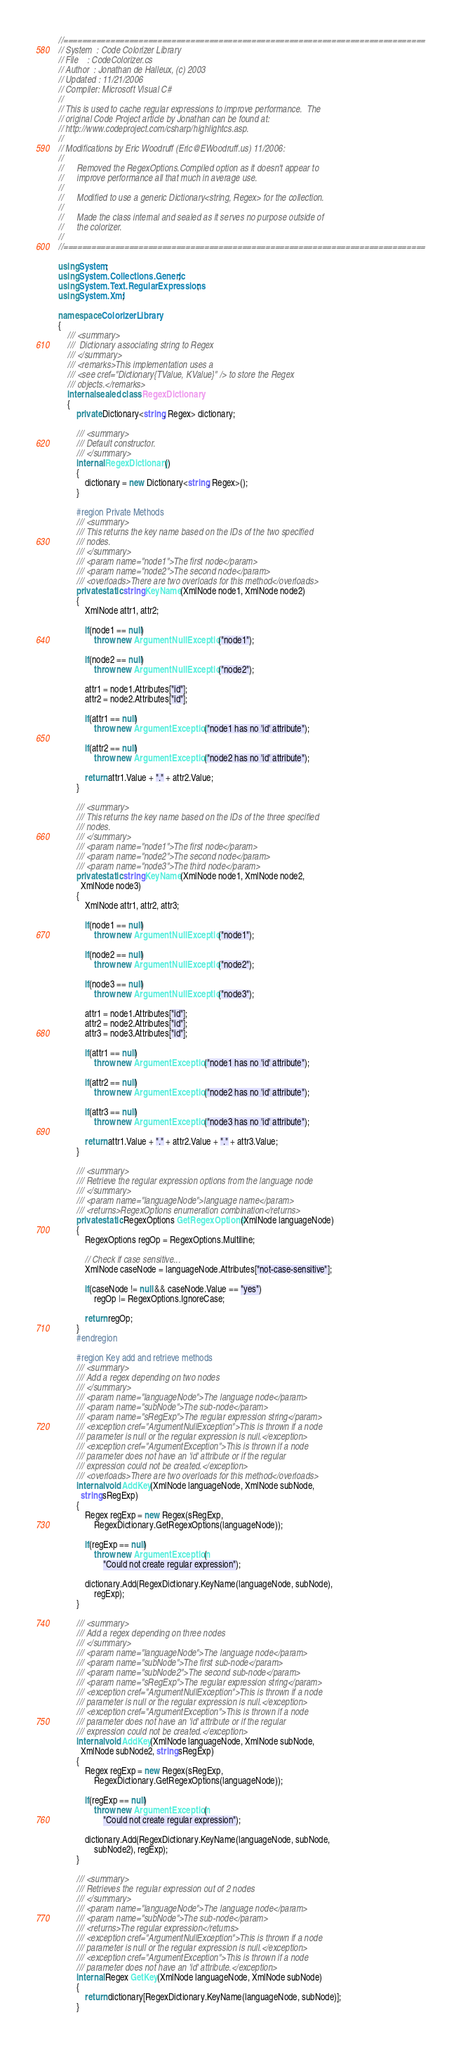Convert code to text. <code><loc_0><loc_0><loc_500><loc_500><_C#_>//=============================================================================
// System  : Code Colorizer Library
// File    : CodeColorizer.cs
// Author  : Jonathan de Halleux, (c) 2003
// Updated : 11/21/2006
// Compiler: Microsoft Visual C#
//
// This is used to cache regular expressions to improve performance.  The
// original Code Project article by Jonathan can be found at:
// http://www.codeproject.com/csharp/highlightcs.asp.
//
// Modifications by Eric Woodruff (Eric@EWoodruff.us) 11/2006:
//
//      Removed the RegexOptions.Compiled option as it doesn't appear to
//      improve performance all that much in average use.
//
//      Modified to use a generic Dictionary<string, Regex> for the collection.
//
//      Made the class internal and sealed as it serves no purpose outside of
//      the colorizer.
//
//=============================================================================

using System;
using System.Collections.Generic;
using System.Text.RegularExpressions;
using System.Xml;

namespace ColorizerLibrary
{
	/// <summary>
	///  Dictionary associating string to Regex
	/// </summary>
	/// <remarks>This implementation uses a
    /// <see cref="Dictionary{TValue, KValue}" /> to store the Regex
    /// objects.</remarks>
	internal sealed class RegexDictionary
	{
        private Dictionary<string, Regex> dictionary;

		/// <summary>
		/// Default constructor.
		/// </summary>
		internal RegexDictionary()
		{
            dictionary = new Dictionary<string, Regex>();
		}

		#region Private Methods
        /// <summary>
        /// This returns the key name based on the IDs of the two specified
        /// nodes.
        /// </summary>
        /// <param name="node1">The first node</param>
        /// <param name="node2">The second node</param>
        /// <overloads>There are two overloads for this method</overloads>
        private static string KeyName(XmlNode node1, XmlNode node2)
        {
            XmlNode attr1, attr2;

            if(node1 == null)
                throw new ArgumentNullException("node1");

            if(node2 == null)
                throw new ArgumentNullException("node2");

            attr1 = node1.Attributes["id"];
            attr2 = node2.Attributes["id"];

            if(attr1 == null)
                throw new ArgumentException("node1 has no 'id' attribute");

            if(attr2 == null)
                throw new ArgumentException("node2 has no 'id' attribute");

            return attr1.Value + "." + attr2.Value;
        }

        /// <summary>
        /// This returns the key name based on the IDs of the three specified
        /// nodes.
        /// </summary>
        /// <param name="node1">The first node</param>
        /// <param name="node2">The second node</param>
        /// <param name="node3">The third node</param>
        private static string KeyName(XmlNode node1, XmlNode node2,
          XmlNode node3)
        {
            XmlNode attr1, attr2, attr3;

            if(node1 == null)
                throw new ArgumentNullException("node1");

            if(node2 == null)
                throw new ArgumentNullException("node2");

            if(node3 == null)
                throw new ArgumentNullException("node3");

            attr1 = node1.Attributes["id"];
            attr2 = node2.Attributes["id"];
            attr3 = node3.Attributes["id"];

            if(attr1 == null)
                throw new ArgumentException("node1 has no 'id' attribute");

            if(attr2 == null)
                throw new ArgumentException("node2 has no 'id' attribute");

            if(attr3 == null)
                throw new ArgumentException("node3 has no 'id' attribute");

            return attr1.Value + "." + attr2.Value + "." + attr3.Value;
        }

		/// <summary>
		/// Retrieve the regular expression options from the language node
		/// </summary>
		/// <param name="languageNode">language name</param>
		/// <returns>RegexOptions enumeration combination</returns>
        private static RegexOptions GetRegexOptions(XmlNode languageNode)
		{
			RegexOptions regOp = RegexOptions.Multiline;

			// Check if case sensitive...
			XmlNode caseNode = languageNode.Attributes["not-case-sensitive"];

			if(caseNode != null && caseNode.Value == "yes")
				regOp |= RegexOptions.IgnoreCase;

			return regOp;
		}
		#endregion

		#region Key add and retrieve methods
		/// <summary>
		/// Add a regex depending on two nodes
		/// </summary>
        /// <param name="languageNode">The language node</param>
        /// <param name="subNode">The sub-node</param>
        /// <param name="sRegExp">The regular expression string</param>
		/// <exception cref="ArgumentNullException">This is thrown if a node
        /// parameter is null or the regular expression is null.</exception>
		/// <exception cref="ArgumentException">This is thrown if a node
        /// parameter does not have an 'id' attribute or if the regular
        /// expression could not be created.</exception>
        /// <overloads>There are two overloads for this method</overloads>
		internal void AddKey(XmlNode languageNode, XmlNode subNode,
          string sRegExp)
		{
			Regex regExp = new Regex(sRegExp,
                RegexDictionary.GetRegexOptions(languageNode));

            if(regExp == null)
				throw new ArgumentException(
                    "Could not create regular expression");

			dictionary.Add(RegexDictionary.KeyName(languageNode, subNode),
                regExp);
		}

		/// <summary>
		/// Add a regex depending on three nodes
		/// </summary>
		/// <param name="languageNode">The language node</param>
		/// <param name="subNode">The first sub-node</param>
		/// <param name="subNode2">The second sub-node</param>
		/// <param name="sRegExp">The regular expression string</param>
		/// <exception cref="ArgumentNullException">This is thrown if a node
        /// parameter is null or the regular expression is null.</exception>
		/// <exception cref="ArgumentException">This is thrown if a node
        /// parameter does not have an 'id' attribute or if the regular
        /// expression could not be created.</exception>
		internal void AddKey(XmlNode languageNode, XmlNode subNode,
          XmlNode subNode2, string sRegExp)
		{
			Regex regExp = new Regex(sRegExp,
                RegexDictionary.GetRegexOptions(languageNode));

			if(regExp == null)
				throw new ArgumentException(
                    "Could not create regular expression");

			dictionary.Add(RegexDictionary.KeyName(languageNode, subNode,
                subNode2), regExp);
		}

		/// <summary>
		/// Retrieves the regular expression out of 2 nodes
		/// </summary>
        /// <param name="languageNode">The language node</param>
        /// <param name="subNode">The sub-node</param>
        /// <returns>The regular expression</returns>
		/// <exception cref="ArgumentNullException">This is thrown if a node
        /// parameter is null or the regular expression is null.</exception>
		/// <exception cref="ArgumentException">This is thrown if a node
        /// parameter does not have an 'id' attribute.</exception>
		internal Regex GetKey(XmlNode languageNode, XmlNode subNode)
		{
			return dictionary[RegexDictionary.KeyName(languageNode, subNode)];
		}
</code> 